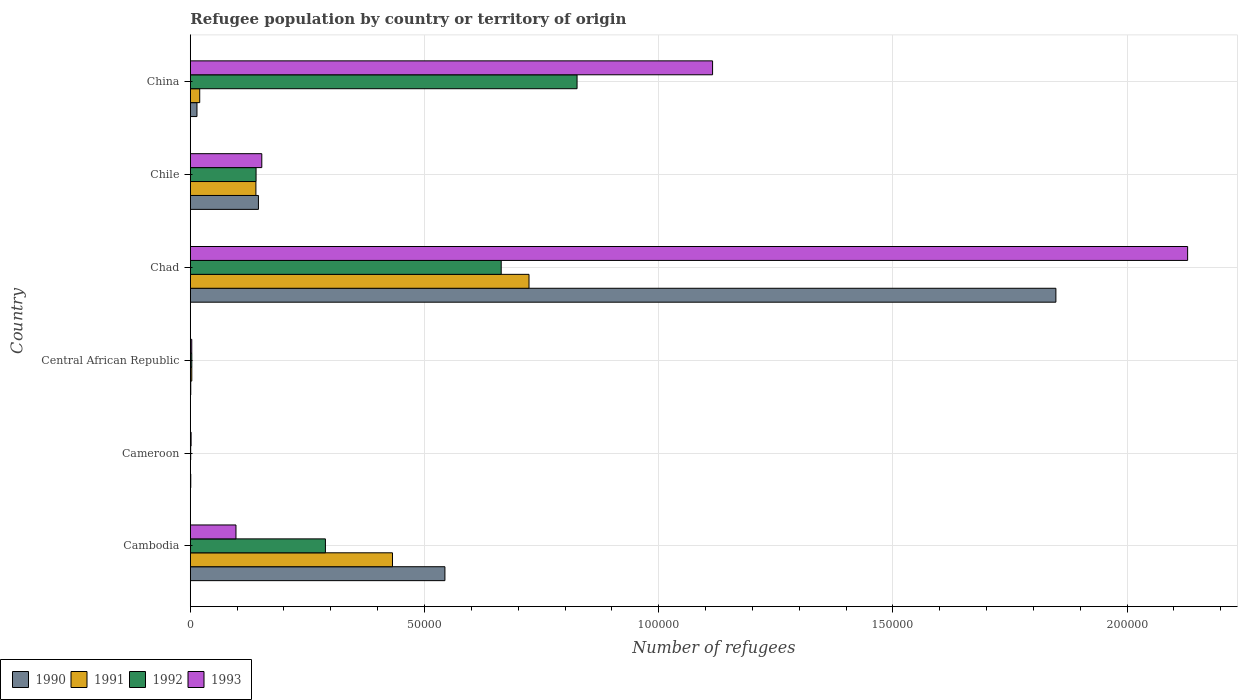How many different coloured bars are there?
Offer a terse response. 4. How many groups of bars are there?
Offer a very short reply. 6. Are the number of bars on each tick of the Y-axis equal?
Offer a terse response. Yes. What is the number of refugees in 1990 in Chad?
Give a very brief answer. 1.85e+05. Across all countries, what is the maximum number of refugees in 1991?
Provide a short and direct response. 7.23e+04. Across all countries, what is the minimum number of refugees in 1993?
Your answer should be compact. 173. In which country was the number of refugees in 1990 maximum?
Provide a succinct answer. Chad. In which country was the number of refugees in 1993 minimum?
Keep it short and to the point. Cameroon. What is the total number of refugees in 1992 in the graph?
Provide a short and direct response. 1.92e+05. What is the difference between the number of refugees in 1993 in Cambodia and that in China?
Provide a succinct answer. -1.02e+05. What is the difference between the number of refugees in 1992 in Chad and the number of refugees in 1993 in Chile?
Make the answer very short. 5.11e+04. What is the average number of refugees in 1993 per country?
Your answer should be compact. 5.83e+04. What is the difference between the number of refugees in 1993 and number of refugees in 1991 in Cameroon?
Make the answer very short. 172. What is the ratio of the number of refugees in 1992 in Cambodia to that in China?
Keep it short and to the point. 0.35. Is the number of refugees in 1991 in Central African Republic less than that in Chad?
Offer a terse response. Yes. Is the difference between the number of refugees in 1993 in Cameroon and China greater than the difference between the number of refugees in 1991 in Cameroon and China?
Your answer should be very brief. No. What is the difference between the highest and the second highest number of refugees in 1990?
Offer a terse response. 1.30e+05. What is the difference between the highest and the lowest number of refugees in 1990?
Keep it short and to the point. 1.85e+05. Is the sum of the number of refugees in 1991 in Central African Republic and Chile greater than the maximum number of refugees in 1992 across all countries?
Offer a very short reply. No. Is it the case that in every country, the sum of the number of refugees in 1990 and number of refugees in 1993 is greater than the sum of number of refugees in 1992 and number of refugees in 1991?
Ensure brevity in your answer.  No. What does the 2nd bar from the top in China represents?
Keep it short and to the point. 1992. Are all the bars in the graph horizontal?
Offer a very short reply. Yes. How many countries are there in the graph?
Give a very brief answer. 6. Are the values on the major ticks of X-axis written in scientific E-notation?
Make the answer very short. No. Does the graph contain grids?
Offer a terse response. Yes. Where does the legend appear in the graph?
Keep it short and to the point. Bottom left. How many legend labels are there?
Provide a succinct answer. 4. What is the title of the graph?
Ensure brevity in your answer.  Refugee population by country or territory of origin. Does "1993" appear as one of the legend labels in the graph?
Your answer should be very brief. Yes. What is the label or title of the X-axis?
Your answer should be very brief. Number of refugees. What is the label or title of the Y-axis?
Offer a terse response. Country. What is the Number of refugees in 1990 in Cambodia?
Your answer should be very brief. 5.44e+04. What is the Number of refugees of 1991 in Cambodia?
Ensure brevity in your answer.  4.32e+04. What is the Number of refugees in 1992 in Cambodia?
Make the answer very short. 2.89e+04. What is the Number of refugees of 1993 in Cambodia?
Ensure brevity in your answer.  9753. What is the Number of refugees of 1990 in Cameroon?
Ensure brevity in your answer.  100. What is the Number of refugees of 1991 in Cameroon?
Offer a terse response. 1. What is the Number of refugees of 1993 in Cameroon?
Offer a terse response. 173. What is the Number of refugees of 1991 in Central African Republic?
Your answer should be compact. 320. What is the Number of refugees of 1992 in Central African Republic?
Provide a succinct answer. 325. What is the Number of refugees in 1993 in Central African Republic?
Ensure brevity in your answer.  313. What is the Number of refugees in 1990 in Chad?
Make the answer very short. 1.85e+05. What is the Number of refugees of 1991 in Chad?
Keep it short and to the point. 7.23e+04. What is the Number of refugees of 1992 in Chad?
Make the answer very short. 6.64e+04. What is the Number of refugees in 1993 in Chad?
Your answer should be compact. 2.13e+05. What is the Number of refugees in 1990 in Chile?
Offer a very short reply. 1.45e+04. What is the Number of refugees in 1991 in Chile?
Keep it short and to the point. 1.40e+04. What is the Number of refugees in 1992 in Chile?
Provide a succinct answer. 1.40e+04. What is the Number of refugees in 1993 in Chile?
Make the answer very short. 1.53e+04. What is the Number of refugees of 1990 in China?
Ensure brevity in your answer.  1426. What is the Number of refugees of 1991 in China?
Your answer should be compact. 2011. What is the Number of refugees of 1992 in China?
Provide a short and direct response. 8.26e+04. What is the Number of refugees of 1993 in China?
Give a very brief answer. 1.12e+05. Across all countries, what is the maximum Number of refugees in 1990?
Keep it short and to the point. 1.85e+05. Across all countries, what is the maximum Number of refugees of 1991?
Keep it short and to the point. 7.23e+04. Across all countries, what is the maximum Number of refugees in 1992?
Provide a succinct answer. 8.26e+04. Across all countries, what is the maximum Number of refugees of 1993?
Offer a terse response. 2.13e+05. Across all countries, what is the minimum Number of refugees of 1990?
Offer a very short reply. 100. Across all countries, what is the minimum Number of refugees of 1992?
Provide a succinct answer. 83. Across all countries, what is the minimum Number of refugees of 1993?
Your answer should be compact. 173. What is the total Number of refugees in 1990 in the graph?
Give a very brief answer. 2.55e+05. What is the total Number of refugees in 1991 in the graph?
Your response must be concise. 1.32e+05. What is the total Number of refugees of 1992 in the graph?
Offer a terse response. 1.92e+05. What is the total Number of refugees in 1993 in the graph?
Your response must be concise. 3.50e+05. What is the difference between the Number of refugees in 1990 in Cambodia and that in Cameroon?
Ensure brevity in your answer.  5.43e+04. What is the difference between the Number of refugees of 1991 in Cambodia and that in Cameroon?
Provide a succinct answer. 4.32e+04. What is the difference between the Number of refugees of 1992 in Cambodia and that in Cameroon?
Ensure brevity in your answer.  2.88e+04. What is the difference between the Number of refugees in 1993 in Cambodia and that in Cameroon?
Ensure brevity in your answer.  9580. What is the difference between the Number of refugees in 1990 in Cambodia and that in Central African Republic?
Make the answer very short. 5.43e+04. What is the difference between the Number of refugees of 1991 in Cambodia and that in Central African Republic?
Your answer should be compact. 4.28e+04. What is the difference between the Number of refugees of 1992 in Cambodia and that in Central African Republic?
Your answer should be compact. 2.85e+04. What is the difference between the Number of refugees of 1993 in Cambodia and that in Central African Republic?
Give a very brief answer. 9440. What is the difference between the Number of refugees of 1990 in Cambodia and that in Chad?
Your answer should be compact. -1.30e+05. What is the difference between the Number of refugees in 1991 in Cambodia and that in Chad?
Give a very brief answer. -2.92e+04. What is the difference between the Number of refugees in 1992 in Cambodia and that in Chad?
Make the answer very short. -3.75e+04. What is the difference between the Number of refugees in 1993 in Cambodia and that in Chad?
Your response must be concise. -2.03e+05. What is the difference between the Number of refugees of 1990 in Cambodia and that in Chile?
Provide a short and direct response. 3.98e+04. What is the difference between the Number of refugees of 1991 in Cambodia and that in Chile?
Give a very brief answer. 2.92e+04. What is the difference between the Number of refugees of 1992 in Cambodia and that in Chile?
Offer a very short reply. 1.48e+04. What is the difference between the Number of refugees in 1993 in Cambodia and that in Chile?
Offer a terse response. -5514. What is the difference between the Number of refugees of 1990 in Cambodia and that in China?
Keep it short and to the point. 5.29e+04. What is the difference between the Number of refugees of 1991 in Cambodia and that in China?
Provide a succinct answer. 4.12e+04. What is the difference between the Number of refugees in 1992 in Cambodia and that in China?
Make the answer very short. -5.37e+04. What is the difference between the Number of refugees in 1993 in Cambodia and that in China?
Your answer should be compact. -1.02e+05. What is the difference between the Number of refugees of 1991 in Cameroon and that in Central African Republic?
Your response must be concise. -319. What is the difference between the Number of refugees of 1992 in Cameroon and that in Central African Republic?
Offer a very short reply. -242. What is the difference between the Number of refugees of 1993 in Cameroon and that in Central African Republic?
Keep it short and to the point. -140. What is the difference between the Number of refugees in 1990 in Cameroon and that in Chad?
Your answer should be very brief. -1.85e+05. What is the difference between the Number of refugees in 1991 in Cameroon and that in Chad?
Provide a short and direct response. -7.23e+04. What is the difference between the Number of refugees in 1992 in Cameroon and that in Chad?
Your response must be concise. -6.63e+04. What is the difference between the Number of refugees in 1993 in Cameroon and that in Chad?
Ensure brevity in your answer.  -2.13e+05. What is the difference between the Number of refugees of 1990 in Cameroon and that in Chile?
Your response must be concise. -1.44e+04. What is the difference between the Number of refugees in 1991 in Cameroon and that in Chile?
Your response must be concise. -1.40e+04. What is the difference between the Number of refugees in 1992 in Cameroon and that in Chile?
Give a very brief answer. -1.40e+04. What is the difference between the Number of refugees of 1993 in Cameroon and that in Chile?
Make the answer very short. -1.51e+04. What is the difference between the Number of refugees in 1990 in Cameroon and that in China?
Offer a terse response. -1326. What is the difference between the Number of refugees of 1991 in Cameroon and that in China?
Offer a terse response. -2010. What is the difference between the Number of refugees in 1992 in Cameroon and that in China?
Your answer should be very brief. -8.25e+04. What is the difference between the Number of refugees of 1993 in Cameroon and that in China?
Your response must be concise. -1.11e+05. What is the difference between the Number of refugees in 1990 in Central African Republic and that in Chad?
Provide a short and direct response. -1.85e+05. What is the difference between the Number of refugees of 1991 in Central African Republic and that in Chad?
Provide a succinct answer. -7.20e+04. What is the difference between the Number of refugees in 1992 in Central African Republic and that in Chad?
Your response must be concise. -6.61e+04. What is the difference between the Number of refugees in 1993 in Central African Republic and that in Chad?
Offer a terse response. -2.13e+05. What is the difference between the Number of refugees in 1990 in Central African Republic and that in Chile?
Your response must be concise. -1.44e+04. What is the difference between the Number of refugees of 1991 in Central African Republic and that in Chile?
Offer a terse response. -1.37e+04. What is the difference between the Number of refugees of 1992 in Central African Republic and that in Chile?
Offer a terse response. -1.37e+04. What is the difference between the Number of refugees in 1993 in Central African Republic and that in Chile?
Your answer should be compact. -1.50e+04. What is the difference between the Number of refugees in 1990 in Central African Republic and that in China?
Your answer should be very brief. -1326. What is the difference between the Number of refugees in 1991 in Central African Republic and that in China?
Make the answer very short. -1691. What is the difference between the Number of refugees of 1992 in Central African Republic and that in China?
Give a very brief answer. -8.23e+04. What is the difference between the Number of refugees in 1993 in Central African Republic and that in China?
Your response must be concise. -1.11e+05. What is the difference between the Number of refugees in 1990 in Chad and that in Chile?
Your answer should be very brief. 1.70e+05. What is the difference between the Number of refugees of 1991 in Chad and that in Chile?
Your response must be concise. 5.83e+04. What is the difference between the Number of refugees in 1992 in Chad and that in Chile?
Ensure brevity in your answer.  5.23e+04. What is the difference between the Number of refugees in 1993 in Chad and that in Chile?
Keep it short and to the point. 1.98e+05. What is the difference between the Number of refugees of 1990 in Chad and that in China?
Offer a very short reply. 1.83e+05. What is the difference between the Number of refugees of 1991 in Chad and that in China?
Your response must be concise. 7.03e+04. What is the difference between the Number of refugees of 1992 in Chad and that in China?
Ensure brevity in your answer.  -1.62e+04. What is the difference between the Number of refugees in 1993 in Chad and that in China?
Ensure brevity in your answer.  1.01e+05. What is the difference between the Number of refugees of 1990 in Chile and that in China?
Make the answer very short. 1.31e+04. What is the difference between the Number of refugees of 1991 in Chile and that in China?
Keep it short and to the point. 1.20e+04. What is the difference between the Number of refugees in 1992 in Chile and that in China?
Offer a terse response. -6.85e+04. What is the difference between the Number of refugees in 1993 in Chile and that in China?
Your answer should be very brief. -9.62e+04. What is the difference between the Number of refugees of 1990 in Cambodia and the Number of refugees of 1991 in Cameroon?
Provide a succinct answer. 5.44e+04. What is the difference between the Number of refugees in 1990 in Cambodia and the Number of refugees in 1992 in Cameroon?
Your response must be concise. 5.43e+04. What is the difference between the Number of refugees of 1990 in Cambodia and the Number of refugees of 1993 in Cameroon?
Your response must be concise. 5.42e+04. What is the difference between the Number of refugees in 1991 in Cambodia and the Number of refugees in 1992 in Cameroon?
Keep it short and to the point. 4.31e+04. What is the difference between the Number of refugees in 1991 in Cambodia and the Number of refugees in 1993 in Cameroon?
Your response must be concise. 4.30e+04. What is the difference between the Number of refugees of 1992 in Cambodia and the Number of refugees of 1993 in Cameroon?
Make the answer very short. 2.87e+04. What is the difference between the Number of refugees of 1990 in Cambodia and the Number of refugees of 1991 in Central African Republic?
Provide a succinct answer. 5.40e+04. What is the difference between the Number of refugees of 1990 in Cambodia and the Number of refugees of 1992 in Central African Republic?
Keep it short and to the point. 5.40e+04. What is the difference between the Number of refugees of 1990 in Cambodia and the Number of refugees of 1993 in Central African Republic?
Offer a terse response. 5.41e+04. What is the difference between the Number of refugees of 1991 in Cambodia and the Number of refugees of 1992 in Central African Republic?
Make the answer very short. 4.28e+04. What is the difference between the Number of refugees of 1991 in Cambodia and the Number of refugees of 1993 in Central African Republic?
Keep it short and to the point. 4.29e+04. What is the difference between the Number of refugees of 1992 in Cambodia and the Number of refugees of 1993 in Central African Republic?
Provide a short and direct response. 2.85e+04. What is the difference between the Number of refugees in 1990 in Cambodia and the Number of refugees in 1991 in Chad?
Ensure brevity in your answer.  -1.80e+04. What is the difference between the Number of refugees in 1990 in Cambodia and the Number of refugees in 1992 in Chad?
Your answer should be compact. -1.20e+04. What is the difference between the Number of refugees of 1990 in Cambodia and the Number of refugees of 1993 in Chad?
Your response must be concise. -1.59e+05. What is the difference between the Number of refugees in 1991 in Cambodia and the Number of refugees in 1992 in Chad?
Make the answer very short. -2.32e+04. What is the difference between the Number of refugees of 1991 in Cambodia and the Number of refugees of 1993 in Chad?
Offer a terse response. -1.70e+05. What is the difference between the Number of refugees of 1992 in Cambodia and the Number of refugees of 1993 in Chad?
Offer a very short reply. -1.84e+05. What is the difference between the Number of refugees in 1990 in Cambodia and the Number of refugees in 1991 in Chile?
Offer a terse response. 4.04e+04. What is the difference between the Number of refugees in 1990 in Cambodia and the Number of refugees in 1992 in Chile?
Keep it short and to the point. 4.03e+04. What is the difference between the Number of refugees in 1990 in Cambodia and the Number of refugees in 1993 in Chile?
Give a very brief answer. 3.91e+04. What is the difference between the Number of refugees of 1991 in Cambodia and the Number of refugees of 1992 in Chile?
Offer a very short reply. 2.91e+04. What is the difference between the Number of refugees of 1991 in Cambodia and the Number of refugees of 1993 in Chile?
Your answer should be compact. 2.79e+04. What is the difference between the Number of refugees in 1992 in Cambodia and the Number of refugees in 1993 in Chile?
Provide a succinct answer. 1.36e+04. What is the difference between the Number of refugees in 1990 in Cambodia and the Number of refugees in 1991 in China?
Offer a very short reply. 5.24e+04. What is the difference between the Number of refugees of 1990 in Cambodia and the Number of refugees of 1992 in China?
Provide a succinct answer. -2.82e+04. What is the difference between the Number of refugees of 1990 in Cambodia and the Number of refugees of 1993 in China?
Your response must be concise. -5.71e+04. What is the difference between the Number of refugees of 1991 in Cambodia and the Number of refugees of 1992 in China?
Your response must be concise. -3.94e+04. What is the difference between the Number of refugees in 1991 in Cambodia and the Number of refugees in 1993 in China?
Offer a terse response. -6.83e+04. What is the difference between the Number of refugees of 1992 in Cambodia and the Number of refugees of 1993 in China?
Offer a terse response. -8.27e+04. What is the difference between the Number of refugees of 1990 in Cameroon and the Number of refugees of 1991 in Central African Republic?
Ensure brevity in your answer.  -220. What is the difference between the Number of refugees of 1990 in Cameroon and the Number of refugees of 1992 in Central African Republic?
Provide a short and direct response. -225. What is the difference between the Number of refugees in 1990 in Cameroon and the Number of refugees in 1993 in Central African Republic?
Give a very brief answer. -213. What is the difference between the Number of refugees of 1991 in Cameroon and the Number of refugees of 1992 in Central African Republic?
Make the answer very short. -324. What is the difference between the Number of refugees of 1991 in Cameroon and the Number of refugees of 1993 in Central African Republic?
Offer a terse response. -312. What is the difference between the Number of refugees of 1992 in Cameroon and the Number of refugees of 1993 in Central African Republic?
Your answer should be very brief. -230. What is the difference between the Number of refugees of 1990 in Cameroon and the Number of refugees of 1991 in Chad?
Your answer should be compact. -7.22e+04. What is the difference between the Number of refugees of 1990 in Cameroon and the Number of refugees of 1992 in Chad?
Offer a terse response. -6.63e+04. What is the difference between the Number of refugees in 1990 in Cameroon and the Number of refugees in 1993 in Chad?
Provide a succinct answer. -2.13e+05. What is the difference between the Number of refugees of 1991 in Cameroon and the Number of refugees of 1992 in Chad?
Offer a terse response. -6.64e+04. What is the difference between the Number of refugees in 1991 in Cameroon and the Number of refugees in 1993 in Chad?
Your answer should be very brief. -2.13e+05. What is the difference between the Number of refugees in 1992 in Cameroon and the Number of refugees in 1993 in Chad?
Offer a terse response. -2.13e+05. What is the difference between the Number of refugees in 1990 in Cameroon and the Number of refugees in 1991 in Chile?
Provide a succinct answer. -1.39e+04. What is the difference between the Number of refugees in 1990 in Cameroon and the Number of refugees in 1992 in Chile?
Offer a very short reply. -1.39e+04. What is the difference between the Number of refugees in 1990 in Cameroon and the Number of refugees in 1993 in Chile?
Your answer should be very brief. -1.52e+04. What is the difference between the Number of refugees in 1991 in Cameroon and the Number of refugees in 1992 in Chile?
Your response must be concise. -1.40e+04. What is the difference between the Number of refugees in 1991 in Cameroon and the Number of refugees in 1993 in Chile?
Your response must be concise. -1.53e+04. What is the difference between the Number of refugees of 1992 in Cameroon and the Number of refugees of 1993 in Chile?
Provide a short and direct response. -1.52e+04. What is the difference between the Number of refugees of 1990 in Cameroon and the Number of refugees of 1991 in China?
Give a very brief answer. -1911. What is the difference between the Number of refugees in 1990 in Cameroon and the Number of refugees in 1992 in China?
Keep it short and to the point. -8.25e+04. What is the difference between the Number of refugees of 1990 in Cameroon and the Number of refugees of 1993 in China?
Give a very brief answer. -1.11e+05. What is the difference between the Number of refugees of 1991 in Cameroon and the Number of refugees of 1992 in China?
Offer a very short reply. -8.26e+04. What is the difference between the Number of refugees of 1991 in Cameroon and the Number of refugees of 1993 in China?
Provide a short and direct response. -1.12e+05. What is the difference between the Number of refugees of 1992 in Cameroon and the Number of refugees of 1993 in China?
Offer a terse response. -1.11e+05. What is the difference between the Number of refugees of 1990 in Central African Republic and the Number of refugees of 1991 in Chad?
Offer a terse response. -7.22e+04. What is the difference between the Number of refugees of 1990 in Central African Republic and the Number of refugees of 1992 in Chad?
Provide a short and direct response. -6.63e+04. What is the difference between the Number of refugees of 1990 in Central African Republic and the Number of refugees of 1993 in Chad?
Offer a terse response. -2.13e+05. What is the difference between the Number of refugees of 1991 in Central African Republic and the Number of refugees of 1992 in Chad?
Ensure brevity in your answer.  -6.61e+04. What is the difference between the Number of refugees in 1991 in Central African Republic and the Number of refugees in 1993 in Chad?
Offer a very short reply. -2.13e+05. What is the difference between the Number of refugees of 1992 in Central African Republic and the Number of refugees of 1993 in Chad?
Keep it short and to the point. -2.13e+05. What is the difference between the Number of refugees of 1990 in Central African Republic and the Number of refugees of 1991 in Chile?
Offer a very short reply. -1.39e+04. What is the difference between the Number of refugees of 1990 in Central African Republic and the Number of refugees of 1992 in Chile?
Ensure brevity in your answer.  -1.39e+04. What is the difference between the Number of refugees in 1990 in Central African Republic and the Number of refugees in 1993 in Chile?
Make the answer very short. -1.52e+04. What is the difference between the Number of refugees in 1991 in Central African Republic and the Number of refugees in 1992 in Chile?
Give a very brief answer. -1.37e+04. What is the difference between the Number of refugees in 1991 in Central African Republic and the Number of refugees in 1993 in Chile?
Make the answer very short. -1.49e+04. What is the difference between the Number of refugees in 1992 in Central African Republic and the Number of refugees in 1993 in Chile?
Keep it short and to the point. -1.49e+04. What is the difference between the Number of refugees of 1990 in Central African Republic and the Number of refugees of 1991 in China?
Offer a terse response. -1911. What is the difference between the Number of refugees in 1990 in Central African Republic and the Number of refugees in 1992 in China?
Your answer should be very brief. -8.25e+04. What is the difference between the Number of refugees of 1990 in Central African Republic and the Number of refugees of 1993 in China?
Provide a succinct answer. -1.11e+05. What is the difference between the Number of refugees in 1991 in Central African Republic and the Number of refugees in 1992 in China?
Provide a succinct answer. -8.23e+04. What is the difference between the Number of refugees of 1991 in Central African Republic and the Number of refugees of 1993 in China?
Ensure brevity in your answer.  -1.11e+05. What is the difference between the Number of refugees of 1992 in Central African Republic and the Number of refugees of 1993 in China?
Provide a succinct answer. -1.11e+05. What is the difference between the Number of refugees in 1990 in Chad and the Number of refugees in 1991 in Chile?
Offer a very short reply. 1.71e+05. What is the difference between the Number of refugees of 1990 in Chad and the Number of refugees of 1992 in Chile?
Give a very brief answer. 1.71e+05. What is the difference between the Number of refugees of 1990 in Chad and the Number of refugees of 1993 in Chile?
Provide a short and direct response. 1.70e+05. What is the difference between the Number of refugees in 1991 in Chad and the Number of refugees in 1992 in Chile?
Offer a terse response. 5.83e+04. What is the difference between the Number of refugees of 1991 in Chad and the Number of refugees of 1993 in Chile?
Provide a succinct answer. 5.71e+04. What is the difference between the Number of refugees of 1992 in Chad and the Number of refugees of 1993 in Chile?
Your answer should be compact. 5.11e+04. What is the difference between the Number of refugees of 1990 in Chad and the Number of refugees of 1991 in China?
Offer a very short reply. 1.83e+05. What is the difference between the Number of refugees in 1990 in Chad and the Number of refugees in 1992 in China?
Provide a short and direct response. 1.02e+05. What is the difference between the Number of refugees of 1990 in Chad and the Number of refugees of 1993 in China?
Make the answer very short. 7.33e+04. What is the difference between the Number of refugees of 1991 in Chad and the Number of refugees of 1992 in China?
Provide a succinct answer. -1.03e+04. What is the difference between the Number of refugees of 1991 in Chad and the Number of refugees of 1993 in China?
Give a very brief answer. -3.92e+04. What is the difference between the Number of refugees of 1992 in Chad and the Number of refugees of 1993 in China?
Ensure brevity in your answer.  -4.51e+04. What is the difference between the Number of refugees in 1990 in Chile and the Number of refugees in 1991 in China?
Keep it short and to the point. 1.25e+04. What is the difference between the Number of refugees of 1990 in Chile and the Number of refugees of 1992 in China?
Your response must be concise. -6.80e+04. What is the difference between the Number of refugees of 1990 in Chile and the Number of refugees of 1993 in China?
Make the answer very short. -9.70e+04. What is the difference between the Number of refugees of 1991 in Chile and the Number of refugees of 1992 in China?
Provide a succinct answer. -6.86e+04. What is the difference between the Number of refugees in 1991 in Chile and the Number of refugees in 1993 in China?
Your answer should be very brief. -9.75e+04. What is the difference between the Number of refugees in 1992 in Chile and the Number of refugees in 1993 in China?
Give a very brief answer. -9.75e+04. What is the average Number of refugees in 1990 per country?
Provide a short and direct response. 4.26e+04. What is the average Number of refugees of 1991 per country?
Ensure brevity in your answer.  2.20e+04. What is the average Number of refugees in 1992 per country?
Your answer should be very brief. 3.20e+04. What is the average Number of refugees of 1993 per country?
Your answer should be compact. 5.83e+04. What is the difference between the Number of refugees of 1990 and Number of refugees of 1991 in Cambodia?
Make the answer very short. 1.12e+04. What is the difference between the Number of refugees in 1990 and Number of refugees in 1992 in Cambodia?
Make the answer very short. 2.55e+04. What is the difference between the Number of refugees in 1990 and Number of refugees in 1993 in Cambodia?
Give a very brief answer. 4.46e+04. What is the difference between the Number of refugees in 1991 and Number of refugees in 1992 in Cambodia?
Your answer should be compact. 1.43e+04. What is the difference between the Number of refugees in 1991 and Number of refugees in 1993 in Cambodia?
Your answer should be very brief. 3.34e+04. What is the difference between the Number of refugees in 1992 and Number of refugees in 1993 in Cambodia?
Provide a short and direct response. 1.91e+04. What is the difference between the Number of refugees of 1990 and Number of refugees of 1991 in Cameroon?
Give a very brief answer. 99. What is the difference between the Number of refugees in 1990 and Number of refugees in 1993 in Cameroon?
Give a very brief answer. -73. What is the difference between the Number of refugees of 1991 and Number of refugees of 1992 in Cameroon?
Offer a terse response. -82. What is the difference between the Number of refugees in 1991 and Number of refugees in 1993 in Cameroon?
Provide a short and direct response. -172. What is the difference between the Number of refugees of 1992 and Number of refugees of 1993 in Cameroon?
Your answer should be very brief. -90. What is the difference between the Number of refugees in 1990 and Number of refugees in 1991 in Central African Republic?
Provide a succinct answer. -220. What is the difference between the Number of refugees of 1990 and Number of refugees of 1992 in Central African Republic?
Your answer should be compact. -225. What is the difference between the Number of refugees of 1990 and Number of refugees of 1993 in Central African Republic?
Your response must be concise. -213. What is the difference between the Number of refugees of 1991 and Number of refugees of 1992 in Central African Republic?
Offer a very short reply. -5. What is the difference between the Number of refugees in 1991 and Number of refugees in 1993 in Central African Republic?
Offer a terse response. 7. What is the difference between the Number of refugees in 1992 and Number of refugees in 1993 in Central African Republic?
Make the answer very short. 12. What is the difference between the Number of refugees in 1990 and Number of refugees in 1991 in Chad?
Ensure brevity in your answer.  1.12e+05. What is the difference between the Number of refugees of 1990 and Number of refugees of 1992 in Chad?
Your response must be concise. 1.18e+05. What is the difference between the Number of refugees of 1990 and Number of refugees of 1993 in Chad?
Provide a short and direct response. -2.81e+04. What is the difference between the Number of refugees in 1991 and Number of refugees in 1992 in Chad?
Ensure brevity in your answer.  5938. What is the difference between the Number of refugees of 1991 and Number of refugees of 1993 in Chad?
Ensure brevity in your answer.  -1.41e+05. What is the difference between the Number of refugees in 1992 and Number of refugees in 1993 in Chad?
Provide a short and direct response. -1.47e+05. What is the difference between the Number of refugees of 1990 and Number of refugees of 1991 in Chile?
Offer a very short reply. 541. What is the difference between the Number of refugees in 1990 and Number of refugees in 1992 in Chile?
Offer a terse response. 505. What is the difference between the Number of refugees of 1990 and Number of refugees of 1993 in Chile?
Offer a terse response. -719. What is the difference between the Number of refugees in 1991 and Number of refugees in 1992 in Chile?
Offer a terse response. -36. What is the difference between the Number of refugees of 1991 and Number of refugees of 1993 in Chile?
Give a very brief answer. -1260. What is the difference between the Number of refugees in 1992 and Number of refugees in 1993 in Chile?
Keep it short and to the point. -1224. What is the difference between the Number of refugees in 1990 and Number of refugees in 1991 in China?
Your response must be concise. -585. What is the difference between the Number of refugees of 1990 and Number of refugees of 1992 in China?
Your answer should be compact. -8.12e+04. What is the difference between the Number of refugees of 1990 and Number of refugees of 1993 in China?
Keep it short and to the point. -1.10e+05. What is the difference between the Number of refugees of 1991 and Number of refugees of 1992 in China?
Keep it short and to the point. -8.06e+04. What is the difference between the Number of refugees of 1991 and Number of refugees of 1993 in China?
Your answer should be compact. -1.09e+05. What is the difference between the Number of refugees in 1992 and Number of refugees in 1993 in China?
Ensure brevity in your answer.  -2.89e+04. What is the ratio of the Number of refugees in 1990 in Cambodia to that in Cameroon?
Your answer should be compact. 543.64. What is the ratio of the Number of refugees of 1991 in Cambodia to that in Cameroon?
Your answer should be compact. 4.32e+04. What is the ratio of the Number of refugees in 1992 in Cambodia to that in Cameroon?
Keep it short and to the point. 347.6. What is the ratio of the Number of refugees in 1993 in Cambodia to that in Cameroon?
Your response must be concise. 56.38. What is the ratio of the Number of refugees in 1990 in Cambodia to that in Central African Republic?
Give a very brief answer. 543.64. What is the ratio of the Number of refugees in 1991 in Cambodia to that in Central African Republic?
Keep it short and to the point. 134.9. What is the ratio of the Number of refugees in 1992 in Cambodia to that in Central African Republic?
Your answer should be compact. 88.77. What is the ratio of the Number of refugees in 1993 in Cambodia to that in Central African Republic?
Make the answer very short. 31.16. What is the ratio of the Number of refugees in 1990 in Cambodia to that in Chad?
Offer a terse response. 0.29. What is the ratio of the Number of refugees in 1991 in Cambodia to that in Chad?
Give a very brief answer. 0.6. What is the ratio of the Number of refugees of 1992 in Cambodia to that in Chad?
Ensure brevity in your answer.  0.43. What is the ratio of the Number of refugees in 1993 in Cambodia to that in Chad?
Offer a terse response. 0.05. What is the ratio of the Number of refugees of 1990 in Cambodia to that in Chile?
Offer a very short reply. 3.74. What is the ratio of the Number of refugees of 1991 in Cambodia to that in Chile?
Make the answer very short. 3.08. What is the ratio of the Number of refugees in 1992 in Cambodia to that in Chile?
Give a very brief answer. 2.05. What is the ratio of the Number of refugees in 1993 in Cambodia to that in Chile?
Provide a succinct answer. 0.64. What is the ratio of the Number of refugees in 1990 in Cambodia to that in China?
Offer a terse response. 38.12. What is the ratio of the Number of refugees of 1991 in Cambodia to that in China?
Ensure brevity in your answer.  21.47. What is the ratio of the Number of refugees in 1992 in Cambodia to that in China?
Keep it short and to the point. 0.35. What is the ratio of the Number of refugees in 1993 in Cambodia to that in China?
Ensure brevity in your answer.  0.09. What is the ratio of the Number of refugees in 1991 in Cameroon to that in Central African Republic?
Provide a short and direct response. 0. What is the ratio of the Number of refugees of 1992 in Cameroon to that in Central African Republic?
Keep it short and to the point. 0.26. What is the ratio of the Number of refugees in 1993 in Cameroon to that in Central African Republic?
Offer a very short reply. 0.55. What is the ratio of the Number of refugees of 1992 in Cameroon to that in Chad?
Make the answer very short. 0. What is the ratio of the Number of refugees of 1993 in Cameroon to that in Chad?
Your response must be concise. 0. What is the ratio of the Number of refugees of 1990 in Cameroon to that in Chile?
Keep it short and to the point. 0.01. What is the ratio of the Number of refugees of 1991 in Cameroon to that in Chile?
Give a very brief answer. 0. What is the ratio of the Number of refugees in 1992 in Cameroon to that in Chile?
Offer a very short reply. 0.01. What is the ratio of the Number of refugees of 1993 in Cameroon to that in Chile?
Offer a terse response. 0.01. What is the ratio of the Number of refugees of 1990 in Cameroon to that in China?
Give a very brief answer. 0.07. What is the ratio of the Number of refugees in 1993 in Cameroon to that in China?
Make the answer very short. 0. What is the ratio of the Number of refugees in 1991 in Central African Republic to that in Chad?
Ensure brevity in your answer.  0. What is the ratio of the Number of refugees in 1992 in Central African Republic to that in Chad?
Make the answer very short. 0. What is the ratio of the Number of refugees in 1993 in Central African Republic to that in Chad?
Your response must be concise. 0. What is the ratio of the Number of refugees of 1990 in Central African Republic to that in Chile?
Offer a very short reply. 0.01. What is the ratio of the Number of refugees of 1991 in Central African Republic to that in Chile?
Make the answer very short. 0.02. What is the ratio of the Number of refugees of 1992 in Central African Republic to that in Chile?
Your response must be concise. 0.02. What is the ratio of the Number of refugees of 1993 in Central African Republic to that in Chile?
Keep it short and to the point. 0.02. What is the ratio of the Number of refugees in 1990 in Central African Republic to that in China?
Your answer should be compact. 0.07. What is the ratio of the Number of refugees of 1991 in Central African Republic to that in China?
Make the answer very short. 0.16. What is the ratio of the Number of refugees in 1992 in Central African Republic to that in China?
Ensure brevity in your answer.  0. What is the ratio of the Number of refugees in 1993 in Central African Republic to that in China?
Ensure brevity in your answer.  0. What is the ratio of the Number of refugees of 1990 in Chad to that in Chile?
Provide a short and direct response. 12.7. What is the ratio of the Number of refugees of 1991 in Chad to that in Chile?
Provide a succinct answer. 5.16. What is the ratio of the Number of refugees of 1992 in Chad to that in Chile?
Provide a short and direct response. 4.73. What is the ratio of the Number of refugees in 1993 in Chad to that in Chile?
Offer a terse response. 13.95. What is the ratio of the Number of refugees of 1990 in Chad to that in China?
Keep it short and to the point. 129.6. What is the ratio of the Number of refugees of 1991 in Chad to that in China?
Offer a terse response. 35.96. What is the ratio of the Number of refugees in 1992 in Chad to that in China?
Offer a terse response. 0.8. What is the ratio of the Number of refugees of 1993 in Chad to that in China?
Make the answer very short. 1.91. What is the ratio of the Number of refugees in 1990 in Chile to that in China?
Ensure brevity in your answer.  10.2. What is the ratio of the Number of refugees in 1991 in Chile to that in China?
Your answer should be very brief. 6.97. What is the ratio of the Number of refugees of 1992 in Chile to that in China?
Your answer should be compact. 0.17. What is the ratio of the Number of refugees in 1993 in Chile to that in China?
Give a very brief answer. 0.14. What is the difference between the highest and the second highest Number of refugees in 1990?
Provide a succinct answer. 1.30e+05. What is the difference between the highest and the second highest Number of refugees of 1991?
Your answer should be compact. 2.92e+04. What is the difference between the highest and the second highest Number of refugees in 1992?
Keep it short and to the point. 1.62e+04. What is the difference between the highest and the second highest Number of refugees of 1993?
Your answer should be compact. 1.01e+05. What is the difference between the highest and the lowest Number of refugees of 1990?
Provide a short and direct response. 1.85e+05. What is the difference between the highest and the lowest Number of refugees in 1991?
Ensure brevity in your answer.  7.23e+04. What is the difference between the highest and the lowest Number of refugees of 1992?
Offer a very short reply. 8.25e+04. What is the difference between the highest and the lowest Number of refugees of 1993?
Ensure brevity in your answer.  2.13e+05. 